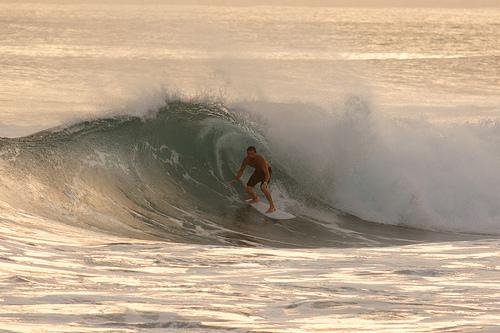Question: who is in the photo?
Choices:
A. A boat captain.
B. A skier.
C. A surfer.
D. A swimmer.
Answer with the letter. Answer: C Question: what color surfboard does the man have?
Choices:
A. Blue.
B. Yellow.
C. White.
D. Gray.
Answer with the letter. Answer: C Question: how is the man staying afloat?
Choices:
A. On a raft.
B. On his back.
C. On a boat.
D. Surfing.
Answer with the letter. Answer: D Question: what is reflected in the water?
Choices:
A. Sunlight.
B. Moonlight.
C. Candlelight.
D. Flashlight.
Answer with the letter. Answer: A Question: what color swim trunks is the man wearing?
Choices:
A. Blue.
B. Red floral.
C. Orange.
D. Black.
Answer with the letter. Answer: D Question: where is the photo?
Choices:
A. A beach.
B. An island.
C. An ocean.
D. A resort.
Answer with the letter. Answer: C 